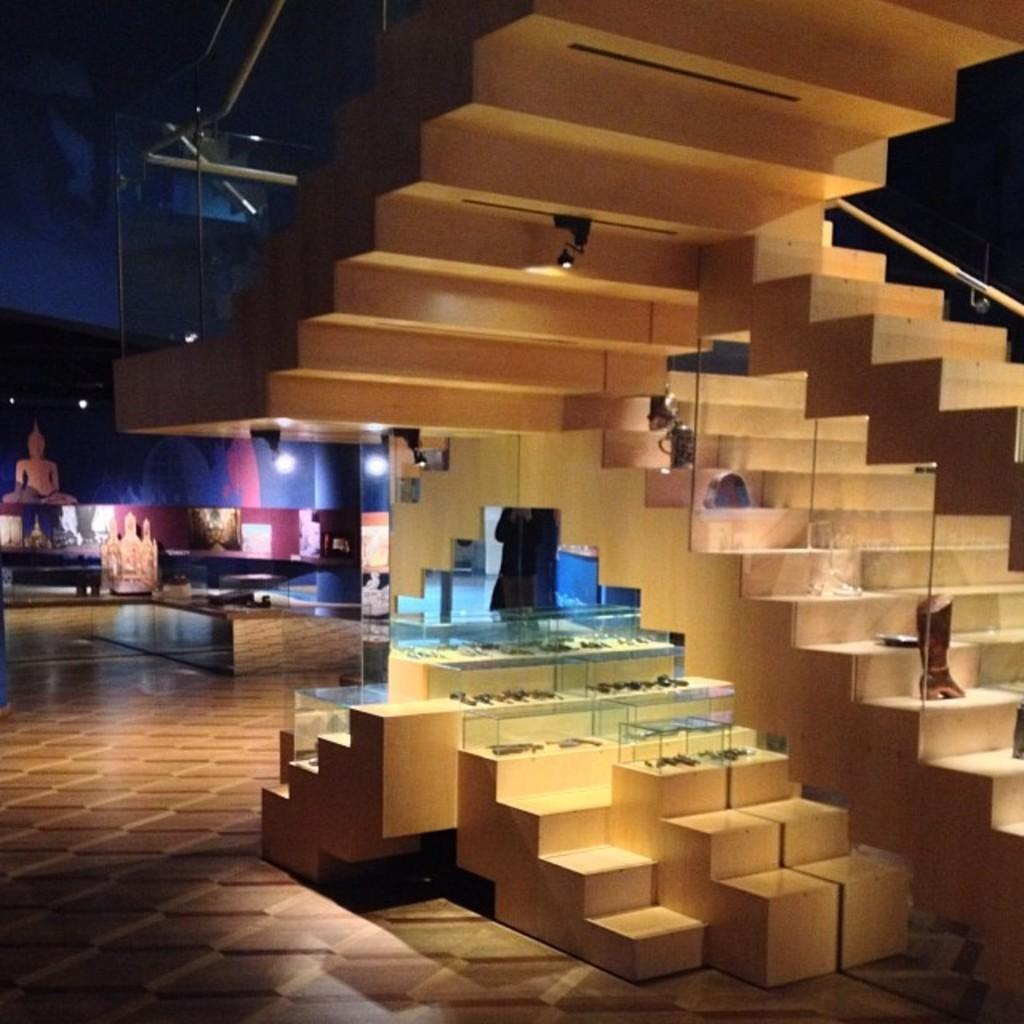What type of structure can be seen in the image? There are stairs in the image. What is placed on the stairs? There are objects on the stairs. What are the glass boxes used for in the image? There are glass boxes in the image, and objects are placed inside them. What can be seen in the background of the image? In the background of the image, there are statues, lights, a wall, and additional objects. Where is the faucet located in the image? There is no faucet present in the image. What type of exchange is taking place between the statues in the background? There is no exchange taking place between the statues in the image; they are stationary. 